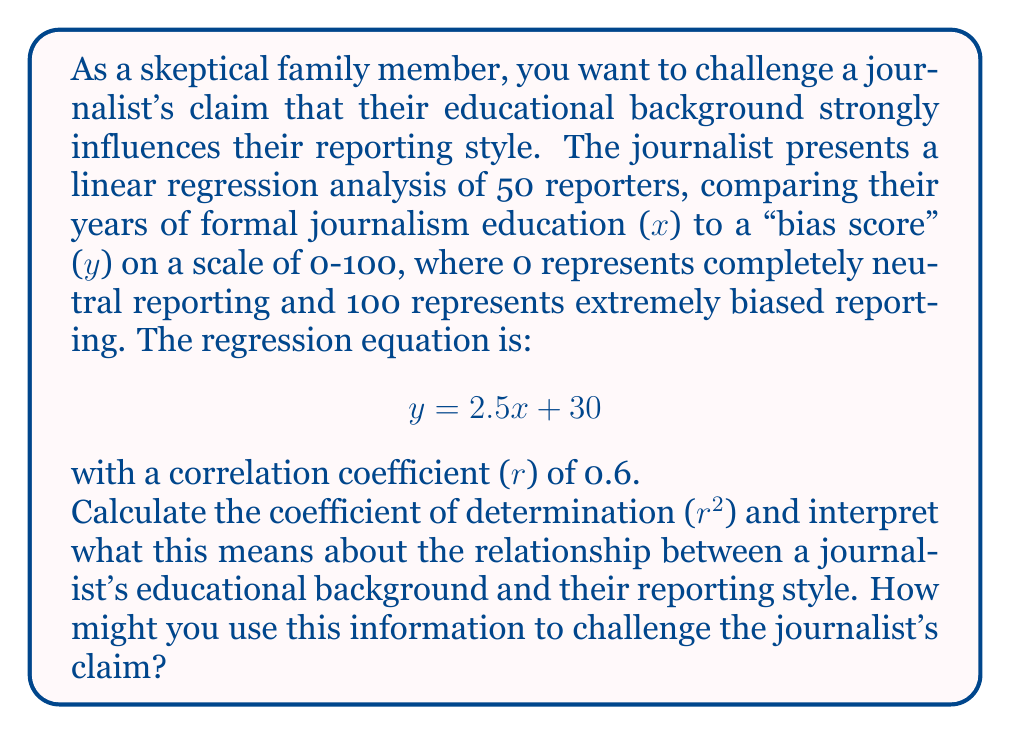Provide a solution to this math problem. To solve this problem, we need to follow these steps:

1) The coefficient of determination ($r^2$) is the square of the correlation coefficient (r).

2) Given: r = 0.6

3) Calculate $r^2$:
   $$ r^2 = (0.6)^2 = 0.36 $$

4) Interpretation of $r^2$:
   The coefficient of determination ($r^2$) represents the proportion of the variance in the dependent variable (bias score) that is predictable from the independent variable (years of journalism education).

   In this case, $r^2 = 0.36$ means that 36% of the variability in the bias score can be explained by the years of journalism education. Conversely, 64% of the variability is due to other factors or random chance.

5) Challenging the journalist's claim:
   While there is a moderate positive correlation (r = 0.6) between years of education and bias score, the $r^2$ value suggests that the majority of the variation in bias scores (64%) cannot be explained by education alone. This indicates that other factors play a significant role in determining a journalist's reporting style.

   Additionally, the regression equation shows that even with zero years of journalism education (x = 0), there's still a baseline bias score of 30. This suggests that factors other than formal education contribute to bias in reporting.

   These points can be used to argue that while education may have some influence on reporting style, it's not as strong or straightforward as the journalist might be claiming, and other factors should be considered.
Answer: $r^2 = 0.36$, indicating that only 36% of the variation in bias scores can be explained by years of journalism education. This suggests that the relationship between a journalist's educational background and their reporting style, while present, is not as strong as the journalist may be claiming, as 64% of the variation is due to other factors. 